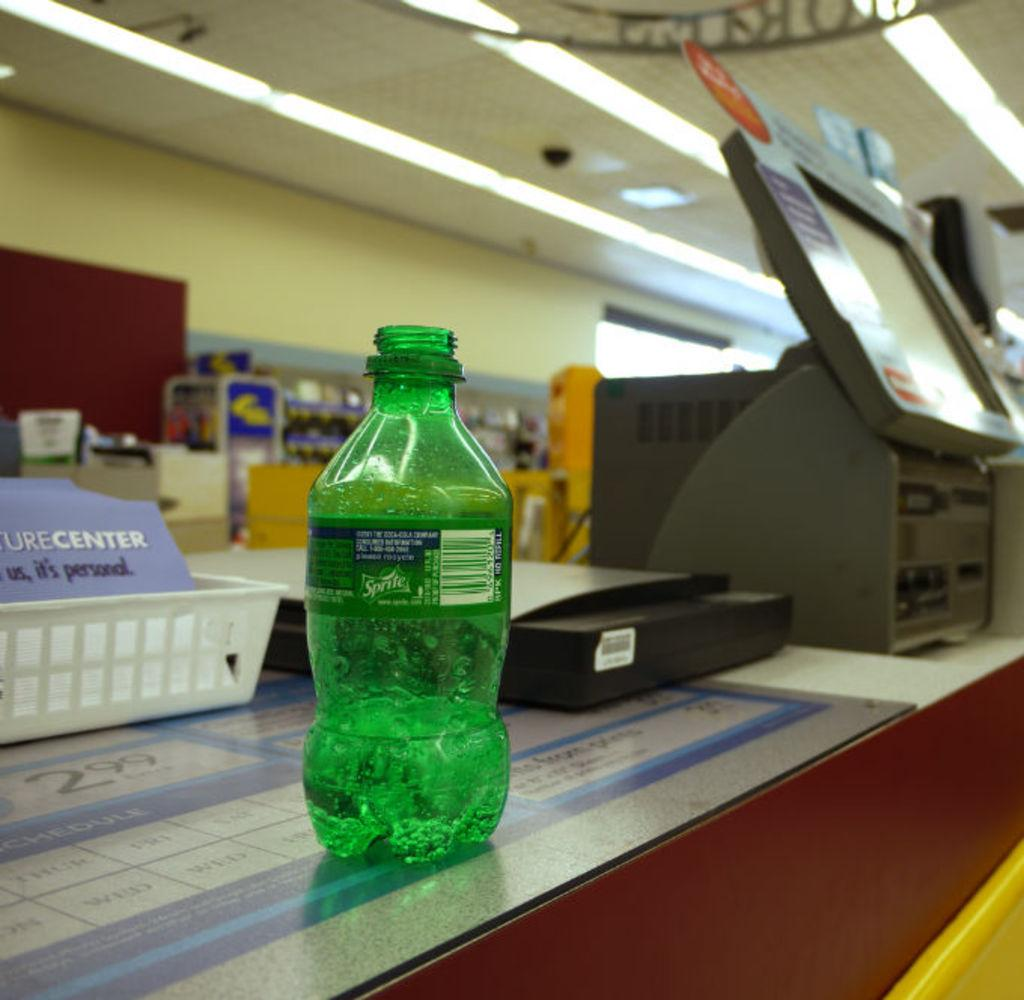What type of object is visible in the image? There is a plastic bottle in the image. What else can be seen on the table in the image? There are other machines on the table in the image. How many clocks are present on the table in the image? There is no mention of clocks in the image, so it is not possible to determine their presence or quantity. 